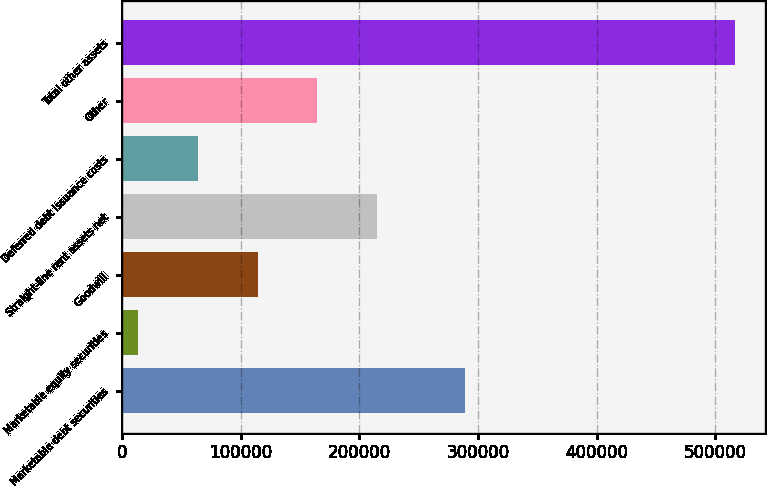Convert chart. <chart><loc_0><loc_0><loc_500><loc_500><bar_chart><fcel>Marketable debt securities<fcel>Marketable equity securities<fcel>Goodwill<fcel>Straight-line rent assets net<fcel>Deferred debt issuance costs<fcel>Other<fcel>Total other assets<nl><fcel>289163<fcel>13761<fcel>114235<fcel>214710<fcel>63998.2<fcel>164473<fcel>516133<nl></chart> 